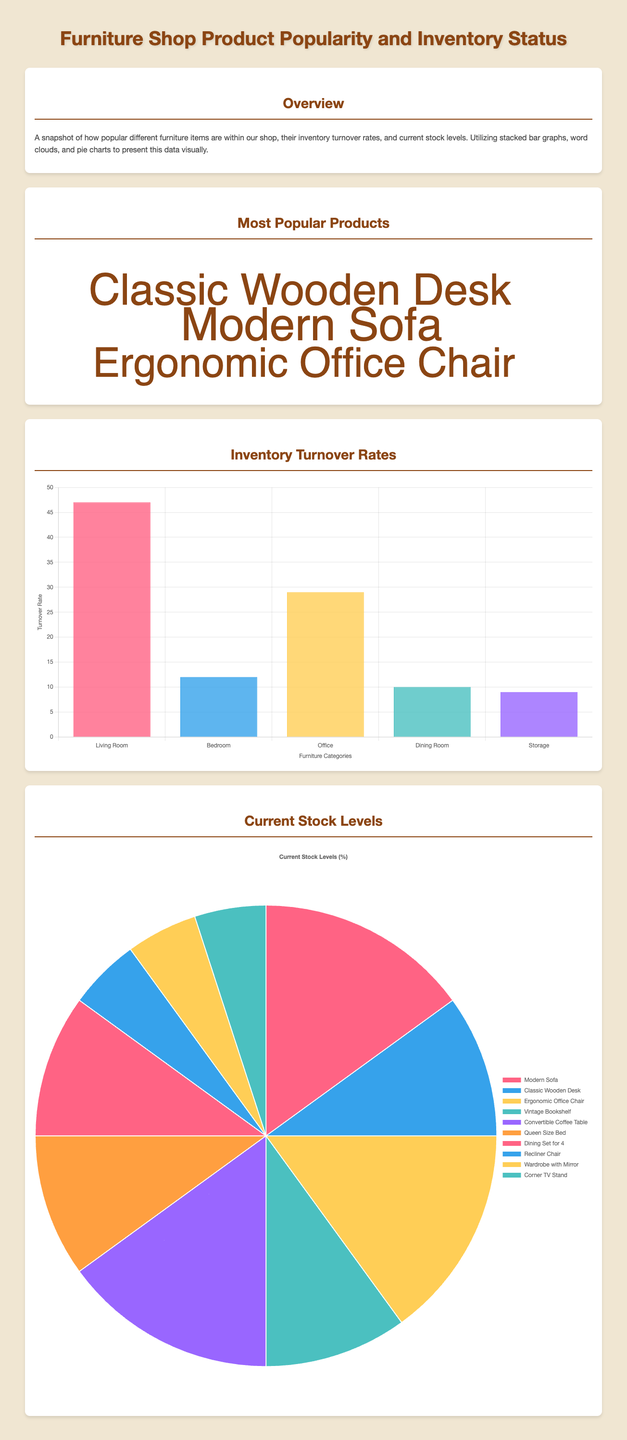What is the most popular product? The most popular product is indicated by the largest word in the word cloud. The largest word is "Modern Sofa."
Answer: Modern Sofa What is the turnover rate for the Office category? The turnover rate is listed on the bar graph under the "Office" label, which shows a turnover rate of 29.
Answer: 29 Which furniture category has the highest turnover rate? The highest turnover rate is represented by the tallest bar in the turnover chart which corresponds to the "Living Room."
Answer: Living Room What percentage of the current stock is represented by the Classic Wooden Desk? The current stock level for each item is represented in a pie chart, indicating the Classic Wooden Desk represents approximately 10 percent of the stock.
Answer: 10 How many different products are represented in the current stock levels pie chart? The pie chart lists different products, which can be counted for clarity, totaling 10 products.
Answer: 10 What is the lowest popularity score in the word cloud? The lowest score in the word cloud corresponds to the word with the smallest size, which is "Corner TV Stand" with a score of 50.
Answer: 50 Which product has a stock level of 5? The pie chart reveals that the products "Recliner Chair," "Wardrobe with Mirror," and "Corner TV Stand" each have a stock level of 5.
Answer: Recliner Chair, Wardrobe with Mirror, Corner TV Stand What visual element is used to represent product popularity? The word cloud visually represents product popularity through the size of words based on their popularity scores.
Answer: Word Cloud What does the color legend in the inventory turnover chart indicate? The color legend in the bar chart is used to distinguish different furniture categories for their turnover rates.
Answer: Furniture Categories 